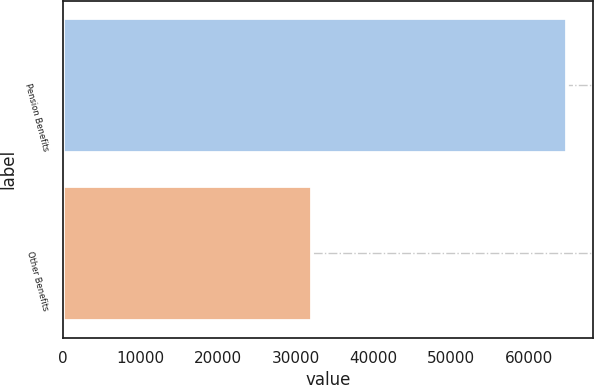Convert chart to OTSL. <chart><loc_0><loc_0><loc_500><loc_500><bar_chart><fcel>Pension Benefits<fcel>Other Benefits<nl><fcel>64939<fcel>32125<nl></chart> 